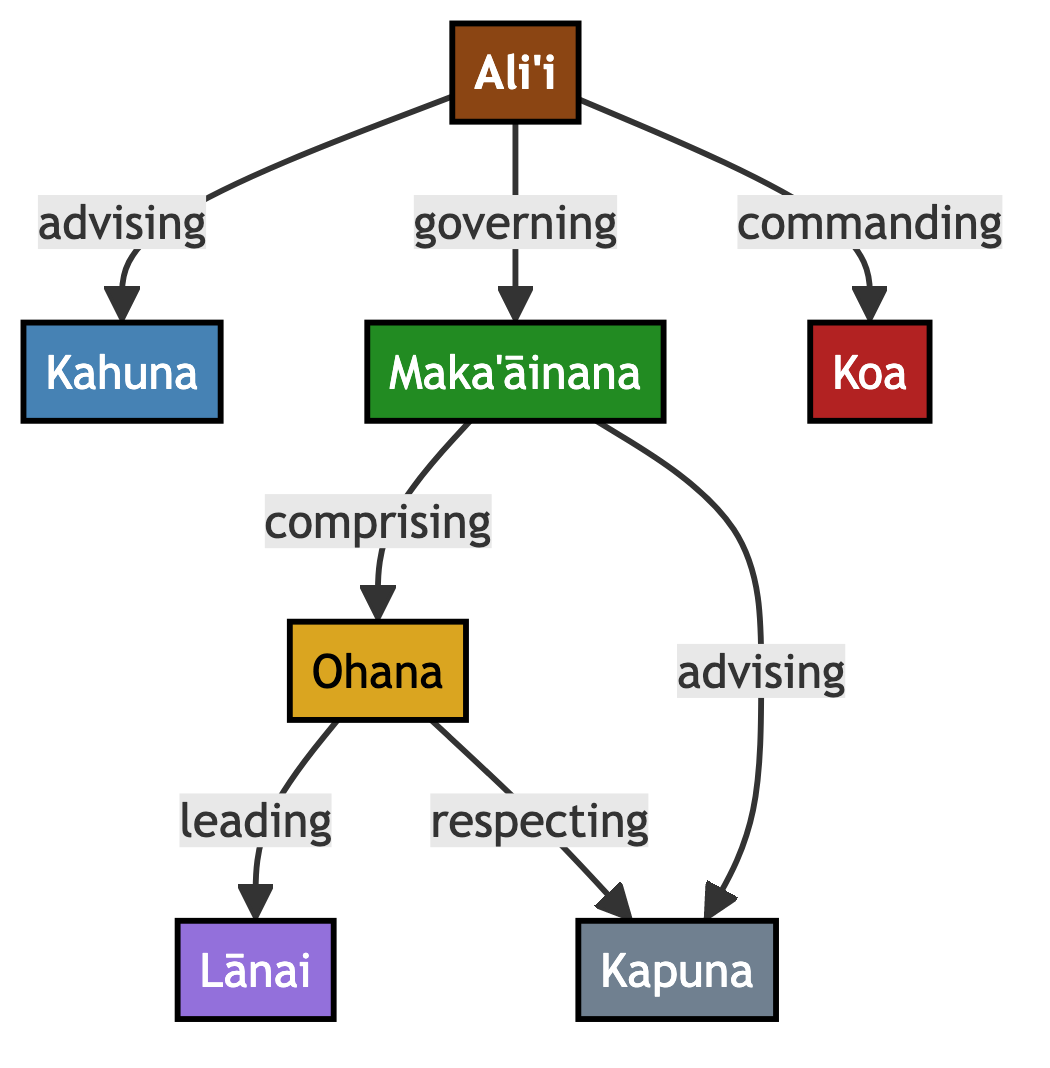What is the highest rank in the social structure? The highest rank represented in the diagram is the Ali'i. It is the primary node and is crucial to the governance and leadership within traditional Hawaiian villages.
Answer: Ali'i How many nodes are present in the diagram? The diagram consists of seven nodes, which are Ali'i, Kahuna, Maka'āinana, Koa, Ohana, Lānai, and Kapuna. Each node represents a distinct role within the social structure.
Answer: 7 What does the Ali'i do concerning the Kahuna? The relationship indicates that the Ali'i advises the Kahuna. This shows a hierarchical interaction where the Ali'i supports and guides the Kahuna's spiritual and social roles.
Answer: advising Who leads the Lānai? The Lānai is led by the Ohana, as indicated by the flow from Ohana to Lānai in the diagram. This reflects the importance of family (Ohana) in guiding and nurturing the communal spaces (Lānai).
Answer: Ohana How does the Maka'āinana relate to the Kapuna? The Maka'āinana advises the Kapuna, which highlights the role of the common people in seeking wisdom or guidance from the elders. This relationship emphasizes respect and the passing of knowledge.
Answer: advising What is the relationship between the Ohana and Koa? The Ohana comprises the Koa, indicating that the families (Ohana) include individuals who take on the warrior role (Koa) within the social hierarchy. This points to the integral role of family in sustaining community defense and leadership.
Answer: comprising Which role commands the Koa? The Koa is commanded by the Ali'i, as shown in the diagram. This relationship demonstrates the military and protective responsibilities that fall under the jurisdiction of the Ali'i's leadership.
Answer: commanding 